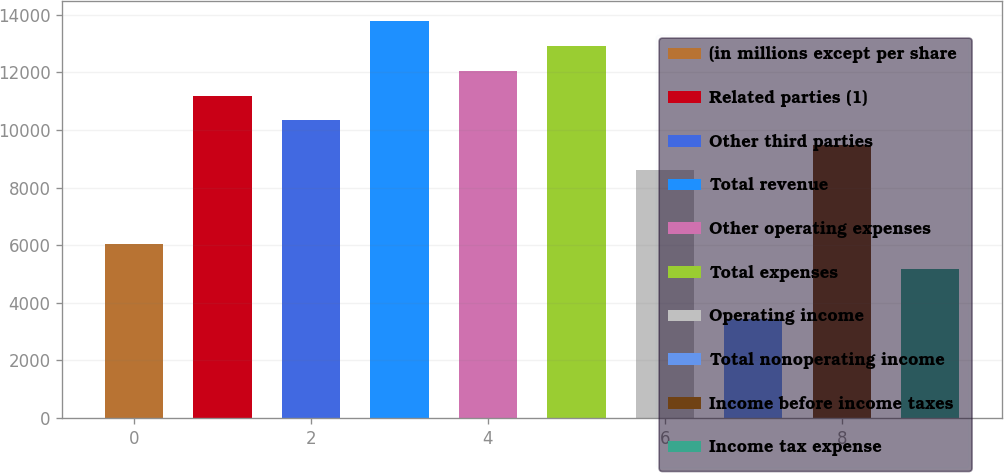<chart> <loc_0><loc_0><loc_500><loc_500><bar_chart><fcel>(in millions except per share<fcel>Related parties (1)<fcel>Other third parties<fcel>Total revenue<fcel>Other operating expenses<fcel>Total expenses<fcel>Operating income<fcel>Total nonoperating income<fcel>Income before income taxes<fcel>Income tax expense<nl><fcel>6029.6<fcel>11194.4<fcel>10333.6<fcel>13776.8<fcel>12055.2<fcel>12916<fcel>8612<fcel>3447.2<fcel>9472.8<fcel>5168.8<nl></chart> 